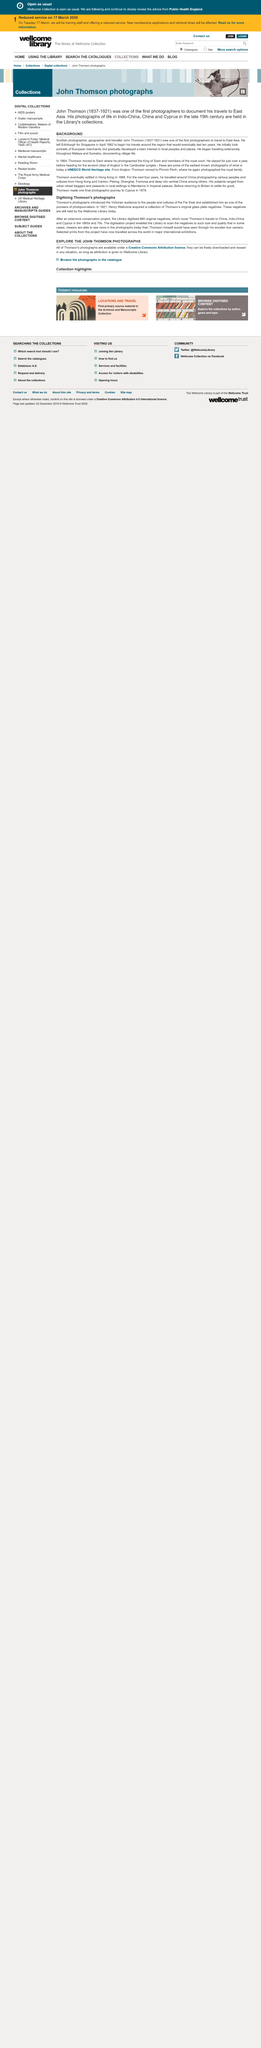Outline some significant characteristics in this image. The man whose photographs of life in Indo-China, China, and Cyprus in the late 19th century are held in the Library's collection was of Scottish nationality. Yes, according to the article "Digitising Thomson's photographs," Donald Thomson was one of the pioneers of photojournalism. The Library has 660 digitized original negatives in its collection. John Thomson died in 1921. Thomson's photographs introduced Victorian audiences to the cultures of the Far East, revealing a side of the world that was previously unknown and exotic to the British public. 